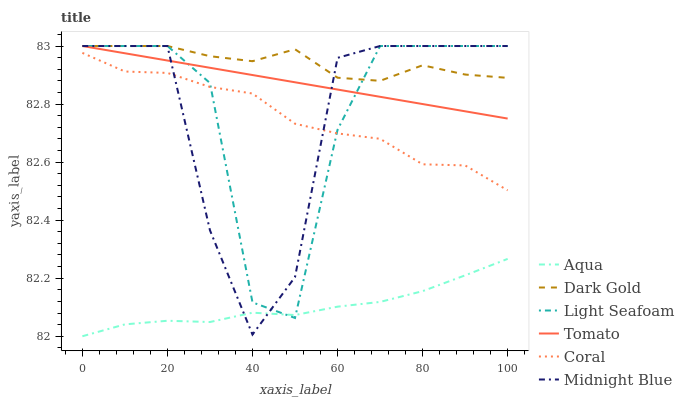Does Aqua have the minimum area under the curve?
Answer yes or no. Yes. Does Dark Gold have the maximum area under the curve?
Answer yes or no. Yes. Does Midnight Blue have the minimum area under the curve?
Answer yes or no. No. Does Midnight Blue have the maximum area under the curve?
Answer yes or no. No. Is Tomato the smoothest?
Answer yes or no. Yes. Is Light Seafoam the roughest?
Answer yes or no. Yes. Is Midnight Blue the smoothest?
Answer yes or no. No. Is Midnight Blue the roughest?
Answer yes or no. No. Does Aqua have the lowest value?
Answer yes or no. Yes. Does Midnight Blue have the lowest value?
Answer yes or no. No. Does Light Seafoam have the highest value?
Answer yes or no. Yes. Does Coral have the highest value?
Answer yes or no. No. Is Aqua less than Dark Gold?
Answer yes or no. Yes. Is Coral greater than Aqua?
Answer yes or no. Yes. Does Coral intersect Midnight Blue?
Answer yes or no. Yes. Is Coral less than Midnight Blue?
Answer yes or no. No. Is Coral greater than Midnight Blue?
Answer yes or no. No. Does Aqua intersect Dark Gold?
Answer yes or no. No. 